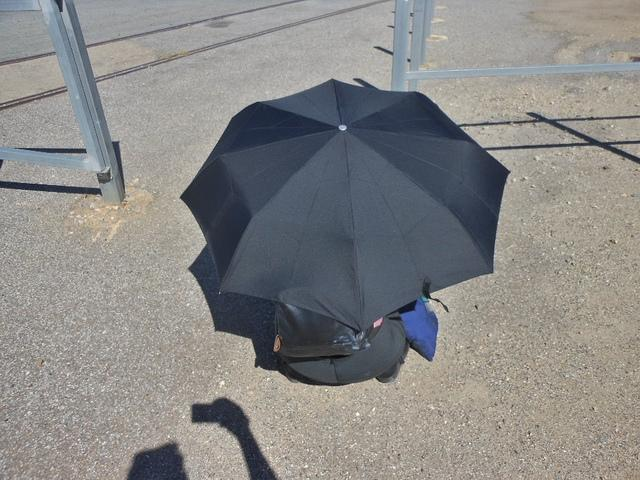Why does the photographer cast a shadow?

Choices:
A) takes photo
B) reflects light
C) blocks light
D) avoids light blocks light 